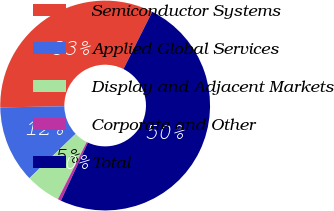<chart> <loc_0><loc_0><loc_500><loc_500><pie_chart><fcel>Semiconductor Systems<fcel>Applied Global Services<fcel>Display and Adjacent Markets<fcel>Corporate and Other<fcel>Total<nl><fcel>32.69%<fcel>11.89%<fcel>5.4%<fcel>0.5%<fcel>49.53%<nl></chart> 